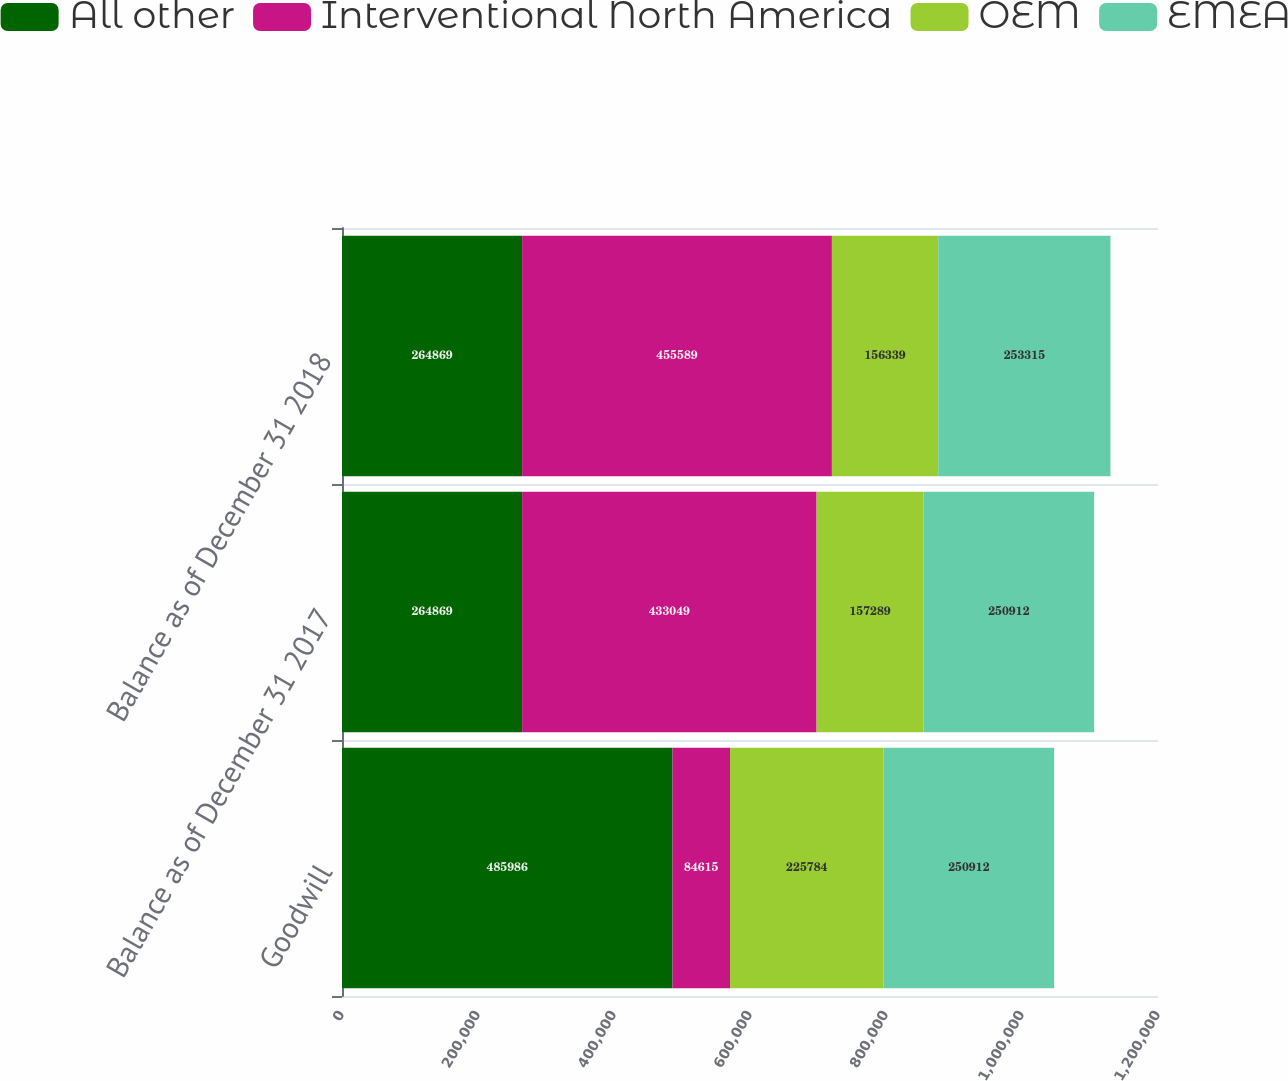Convert chart. <chart><loc_0><loc_0><loc_500><loc_500><stacked_bar_chart><ecel><fcel>Goodwill<fcel>Balance as of December 31 2017<fcel>Balance as of December 31 2018<nl><fcel>All other<fcel>485986<fcel>264869<fcel>264869<nl><fcel>Interventional North America<fcel>84615<fcel>433049<fcel>455589<nl><fcel>OEM<fcel>225784<fcel>157289<fcel>156339<nl><fcel>EMEA<fcel>250912<fcel>250912<fcel>253315<nl></chart> 